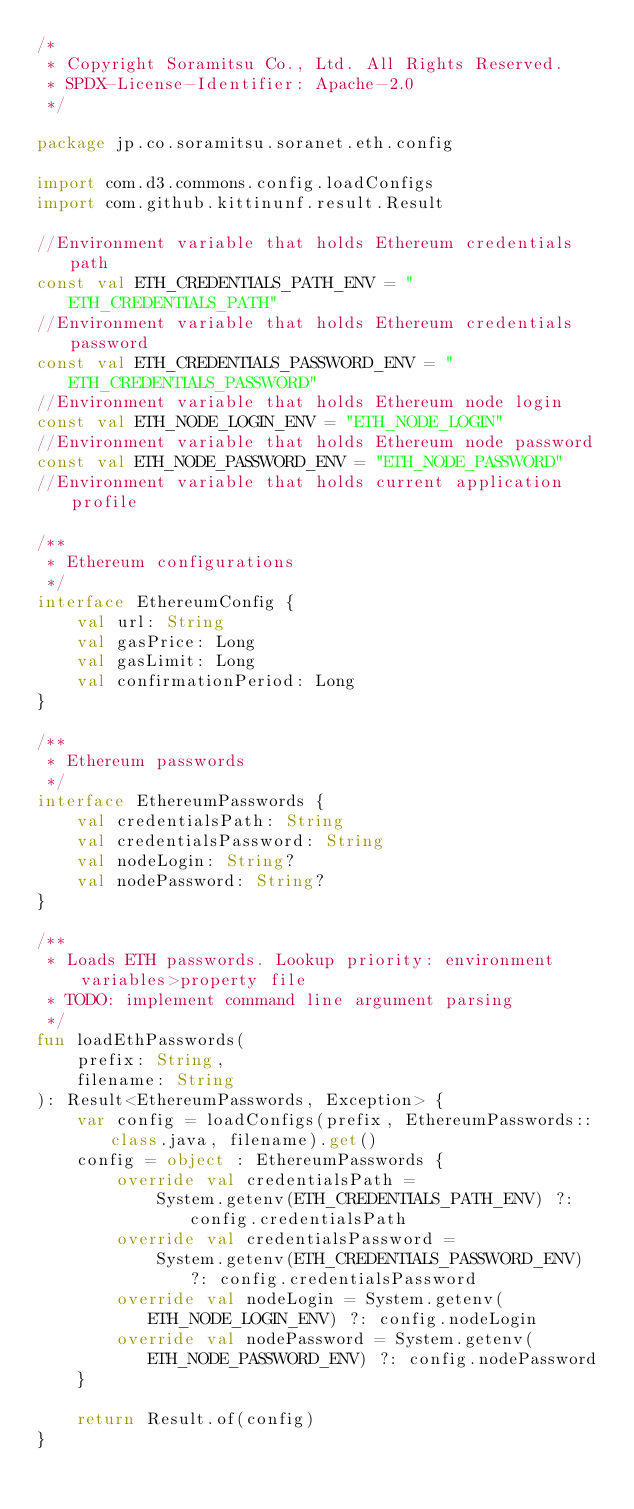<code> <loc_0><loc_0><loc_500><loc_500><_Kotlin_>/*
 * Copyright Soramitsu Co., Ltd. All Rights Reserved.
 * SPDX-License-Identifier: Apache-2.0
 */

package jp.co.soramitsu.soranet.eth.config

import com.d3.commons.config.loadConfigs
import com.github.kittinunf.result.Result

//Environment variable that holds Ethereum credentials path
const val ETH_CREDENTIALS_PATH_ENV = "ETH_CREDENTIALS_PATH"
//Environment variable that holds Ethereum credentials password
const val ETH_CREDENTIALS_PASSWORD_ENV = "ETH_CREDENTIALS_PASSWORD"
//Environment variable that holds Ethereum node login
const val ETH_NODE_LOGIN_ENV = "ETH_NODE_LOGIN"
//Environment variable that holds Ethereum node password
const val ETH_NODE_PASSWORD_ENV = "ETH_NODE_PASSWORD"
//Environment variable that holds current application profile

/**
 * Ethereum configurations
 */
interface EthereumConfig {
    val url: String
    val gasPrice: Long
    val gasLimit: Long
    val confirmationPeriod: Long
}

/**
 * Ethereum passwords
 */
interface EthereumPasswords {
    val credentialsPath: String
    val credentialsPassword: String
    val nodeLogin: String?
    val nodePassword: String?
}

/**
 * Loads ETH passwords. Lookup priority: environment variables>property file
 * TODO: implement command line argument parsing
 */
fun loadEthPasswords(
    prefix: String,
    filename: String
): Result<EthereumPasswords, Exception> {
    var config = loadConfigs(prefix, EthereumPasswords::class.java, filename).get()
    config = object : EthereumPasswords {
        override val credentialsPath =
            System.getenv(ETH_CREDENTIALS_PATH_ENV) ?: config.credentialsPath
        override val credentialsPassword =
            System.getenv(ETH_CREDENTIALS_PASSWORD_ENV) ?: config.credentialsPassword
        override val nodeLogin = System.getenv(ETH_NODE_LOGIN_ENV) ?: config.nodeLogin
        override val nodePassword = System.getenv(ETH_NODE_PASSWORD_ENV) ?: config.nodePassword
    }

    return Result.of(config)
}
</code> 